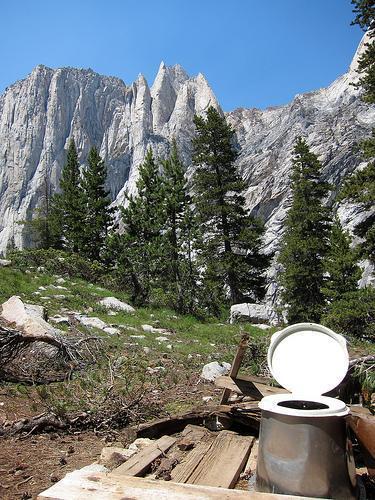How many toilets are there?
Give a very brief answer. 1. 